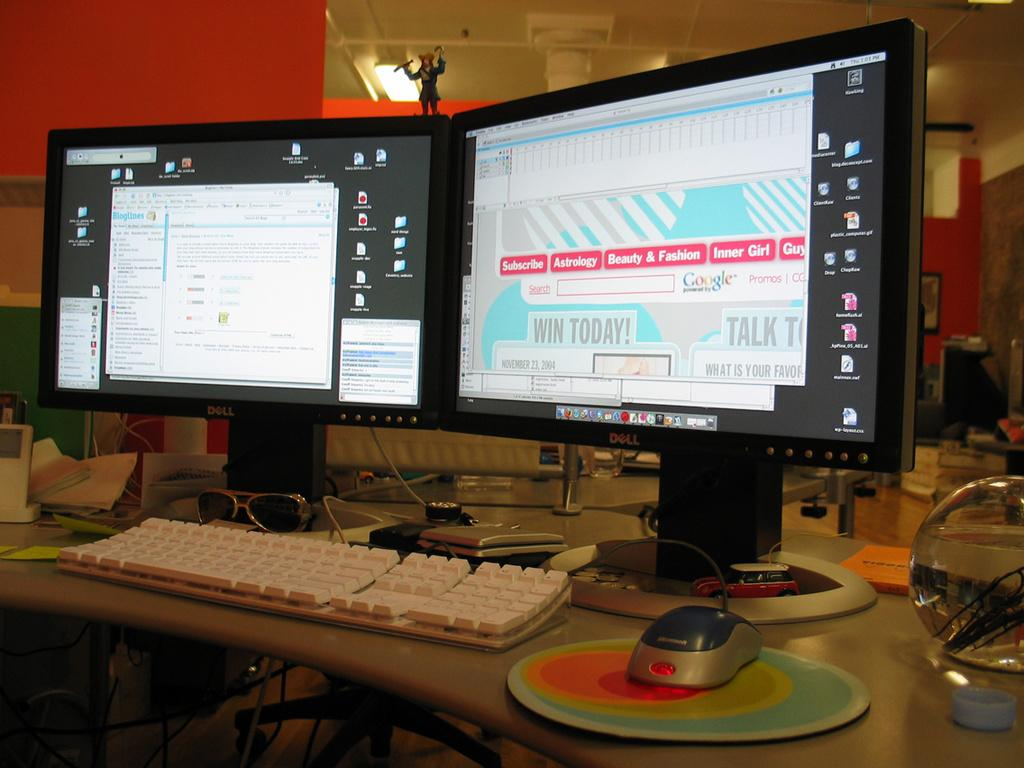Provide a one-sentence caption for the provided image. A computer screen displaying different tabs in pink including Subscribe, Astrology, Beauty & Fashion, and Inner Girl. 